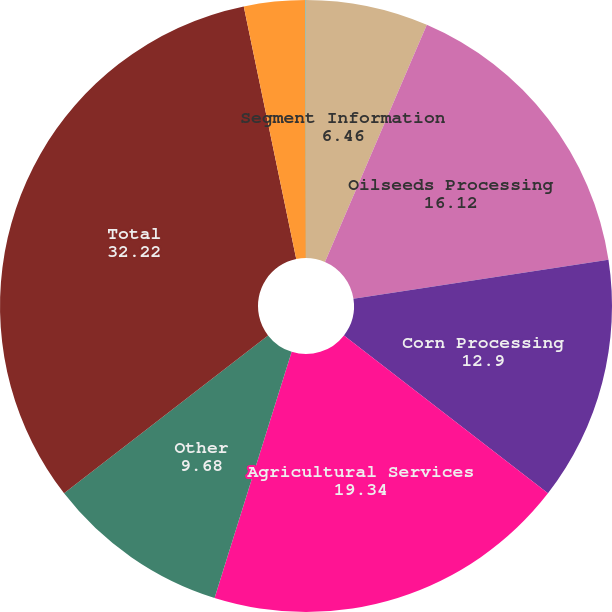<chart> <loc_0><loc_0><loc_500><loc_500><pie_chart><fcel>Segment Information<fcel>Oilseeds Processing<fcel>Corn Processing<fcel>Agricultural Services<fcel>Other<fcel>Total<fcel>Intersegment elimination<fcel>Corporate<nl><fcel>6.46%<fcel>16.12%<fcel>12.9%<fcel>19.34%<fcel>9.68%<fcel>32.22%<fcel>3.24%<fcel>0.02%<nl></chart> 